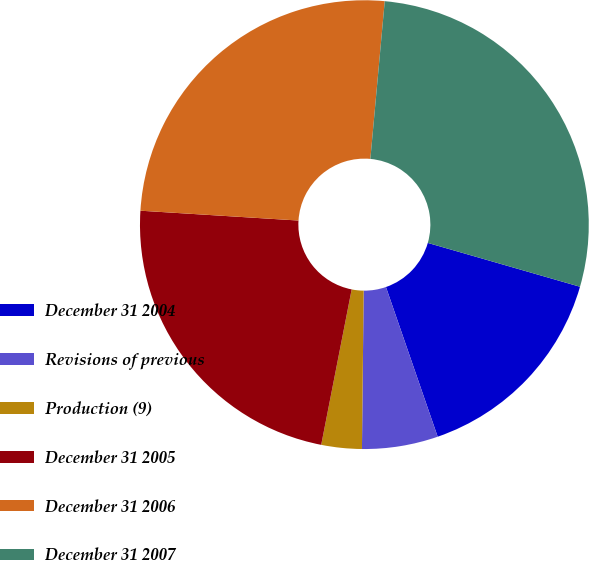Convert chart. <chart><loc_0><loc_0><loc_500><loc_500><pie_chart><fcel>December 31 2004<fcel>Revisions of previous<fcel>Production (9)<fcel>December 31 2005<fcel>December 31 2006<fcel>December 31 2007<nl><fcel>15.24%<fcel>5.47%<fcel>2.91%<fcel>22.91%<fcel>25.46%<fcel>28.02%<nl></chart> 